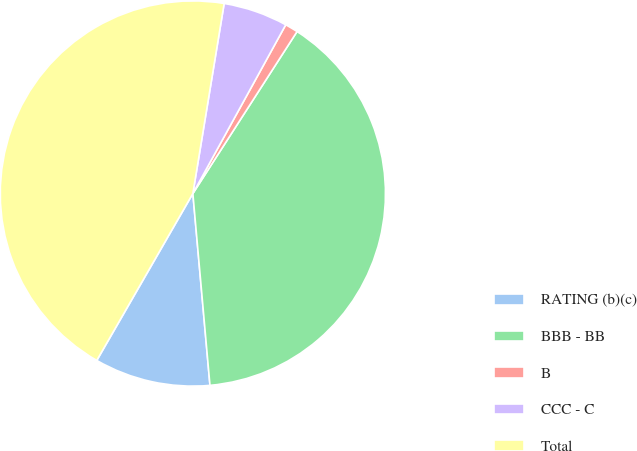Convert chart. <chart><loc_0><loc_0><loc_500><loc_500><pie_chart><fcel>RATING (b)(c)<fcel>BBB - BB<fcel>B<fcel>CCC - C<fcel>Total<nl><fcel>9.73%<fcel>39.49%<fcel>1.09%<fcel>5.41%<fcel>44.29%<nl></chart> 